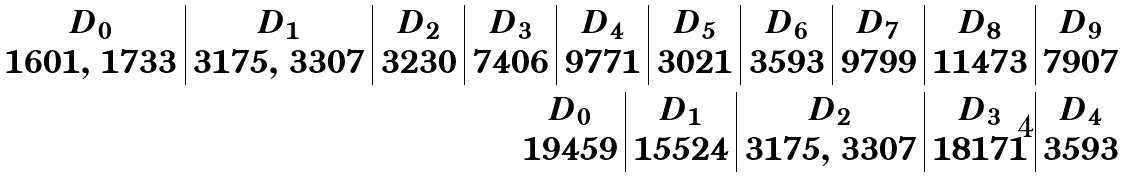<formula> <loc_0><loc_0><loc_500><loc_500>\begin{array} { c | c | c | c | c | c | c | c | c | c } D _ { 0 } & D _ { 1 } & D _ { 2 } & D _ { 3 } & D _ { 4 } & D _ { 5 } & D _ { 6 } & D _ { 7 } & D _ { 8 } & D _ { 9 } \\ 1 6 0 1 , \, 1 7 3 3 & 3 1 7 5 , \, 3 3 0 7 & 3 2 3 0 & 7 4 0 6 & 9 7 7 1 & 3 0 2 1 & 3 5 9 3 & 9 7 9 9 & 1 1 4 7 3 & 7 9 0 7 \end{array} \\ \begin{array} { c | c | c | c | c } D _ { \mathbf 0 } & D _ { \mathbf 1 } & D _ { \mathbf 2 } & D _ { \mathbf 3 } & D _ { \mathbf 4 } \\ 1 9 4 5 9 & 1 5 5 2 4 & 3 1 7 5 , \, 3 3 0 7 & 1 8 1 7 1 & 3 5 9 3 \end{array}</formula> 